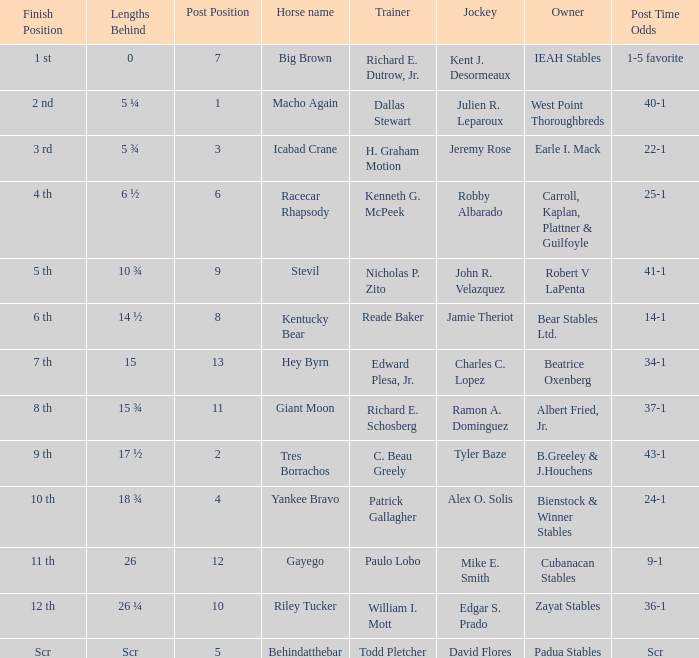What post position corresponds to a "lengths behind" value of 0? 7.0. 